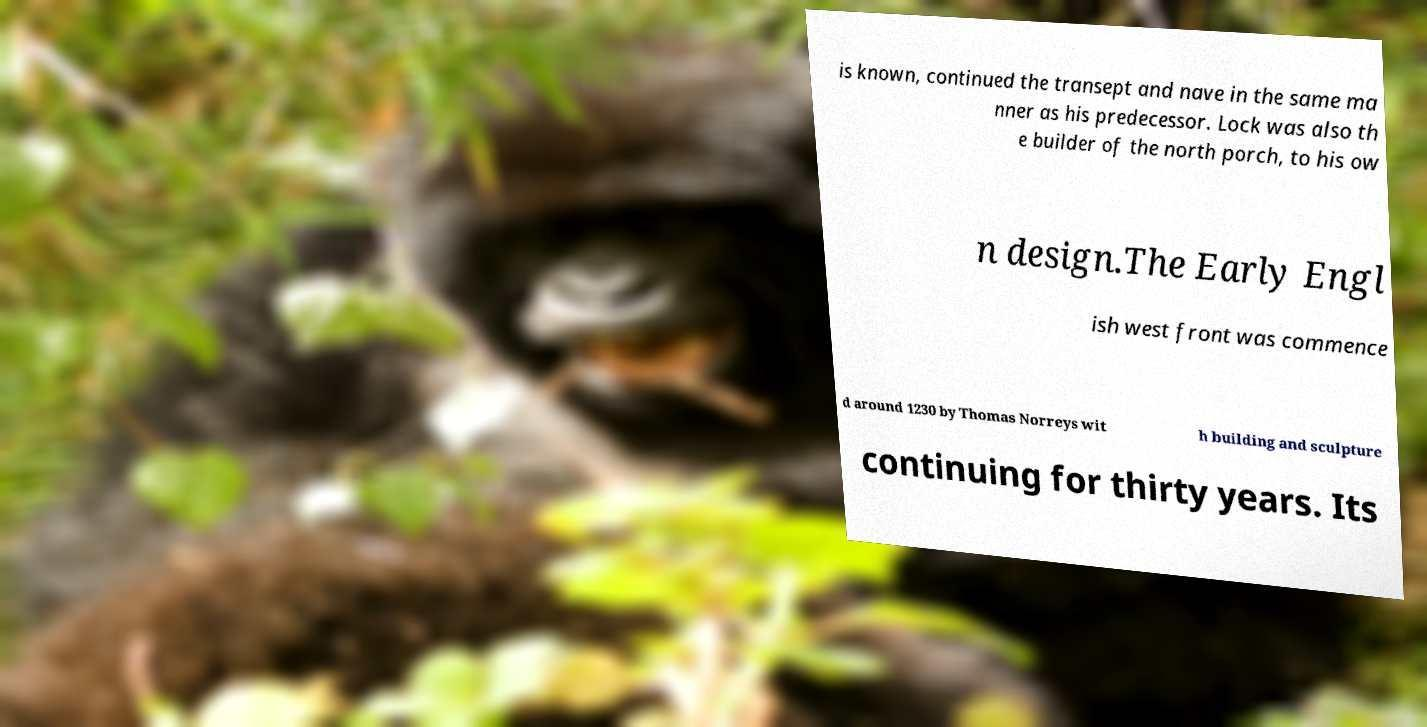Can you accurately transcribe the text from the provided image for me? is known, continued the transept and nave in the same ma nner as his predecessor. Lock was also th e builder of the north porch, to his ow n design.The Early Engl ish west front was commence d around 1230 by Thomas Norreys wit h building and sculpture continuing for thirty years. Its 